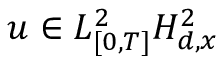Convert formula to latex. <formula><loc_0><loc_0><loc_500><loc_500>u \in L _ { [ 0 , T ] } ^ { 2 } H _ { d , x } ^ { 2 }</formula> 